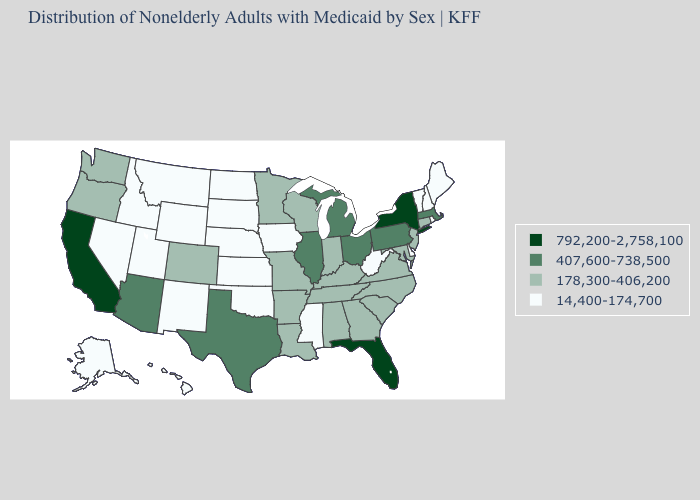Is the legend a continuous bar?
Short answer required. No. Does Florida have the same value as Ohio?
Short answer required. No. What is the value of North Dakota?
Concise answer only. 14,400-174,700. Name the states that have a value in the range 792,200-2,758,100?
Keep it brief. California, Florida, New York. Which states have the lowest value in the USA?
Answer briefly. Alaska, Delaware, Hawaii, Idaho, Iowa, Kansas, Maine, Mississippi, Montana, Nebraska, Nevada, New Hampshire, New Mexico, North Dakota, Oklahoma, Rhode Island, South Dakota, Utah, Vermont, West Virginia, Wyoming. Name the states that have a value in the range 178,300-406,200?
Write a very short answer. Alabama, Arkansas, Colorado, Connecticut, Georgia, Indiana, Kentucky, Louisiana, Maryland, Minnesota, Missouri, New Jersey, North Carolina, Oregon, South Carolina, Tennessee, Virginia, Washington, Wisconsin. Among the states that border Massachusetts , does Vermont have the lowest value?
Give a very brief answer. Yes. Among the states that border West Virginia , which have the lowest value?
Short answer required. Kentucky, Maryland, Virginia. Name the states that have a value in the range 178,300-406,200?
Give a very brief answer. Alabama, Arkansas, Colorado, Connecticut, Georgia, Indiana, Kentucky, Louisiana, Maryland, Minnesota, Missouri, New Jersey, North Carolina, Oregon, South Carolina, Tennessee, Virginia, Washington, Wisconsin. Name the states that have a value in the range 407,600-738,500?
Be succinct. Arizona, Illinois, Massachusetts, Michigan, Ohio, Pennsylvania, Texas. How many symbols are there in the legend?
Quick response, please. 4. Does the map have missing data?
Keep it brief. No. What is the value of Montana?
Short answer required. 14,400-174,700. Which states have the lowest value in the MidWest?
Give a very brief answer. Iowa, Kansas, Nebraska, North Dakota, South Dakota. Is the legend a continuous bar?
Short answer required. No. 